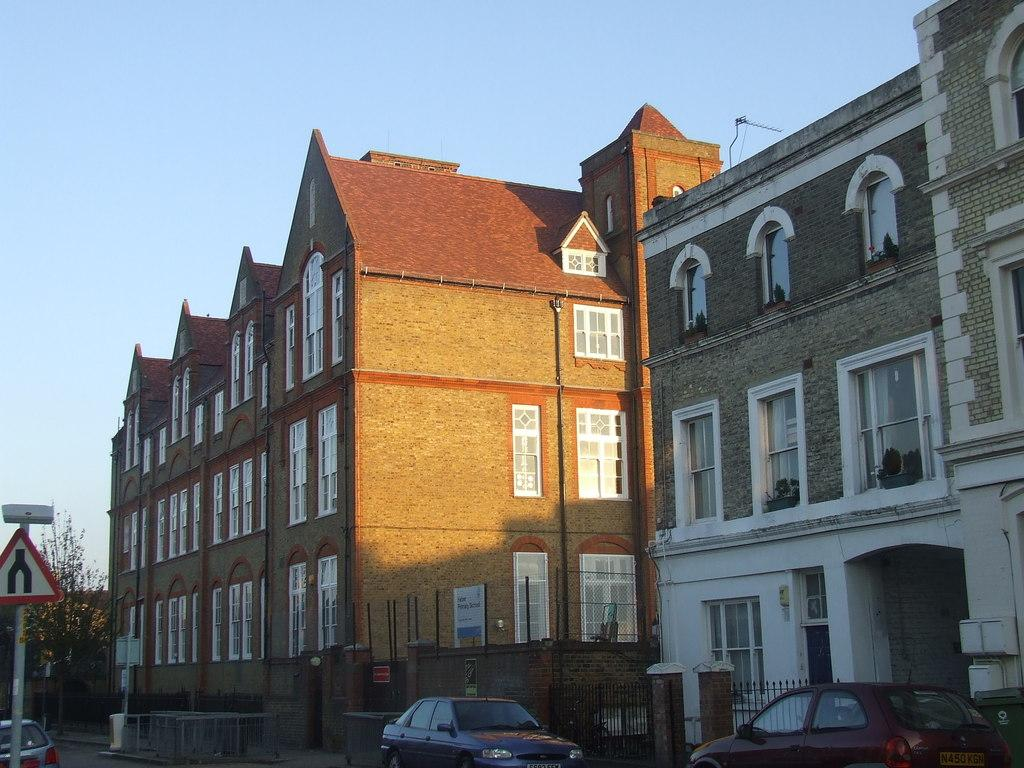What is happening in the image? There are vehicles moving on a road in the image. What can be seen in the background of the image? There are railings, walls, buildings, trees, and the sky visible in the background of the image. Where is the sign board located in the image? The sign board is on the left side of the image. What type of trick can be seen being performed by the vehicles in the image? There is no trick being performed by the vehicles in the image; they are simply moving on a road. What time of day is it in the image, considering the presence of the night or morning? The time of day cannot be determined from the image, as there is no reference to night or morning. 